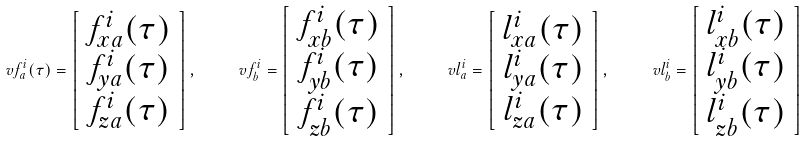Convert formula to latex. <formula><loc_0><loc_0><loc_500><loc_500>\ v f ^ { i } _ { a } ( \tau ) = \left [ \begin{array} { c } f _ { x a } ^ { i } ( \tau ) \\ f _ { y a } ^ { i } ( \tau ) \\ f _ { z a } ^ { i } ( \tau ) \end{array} \right ] , \quad \ v f ^ { i } _ { b } = \left [ \begin{array} { c } f _ { x b } ^ { i } ( \tau ) \\ f _ { y b } ^ { i } ( \tau ) \\ f _ { z b } ^ { i } ( \tau ) \end{array} \right ] , \quad \ v l ^ { i } _ { a } = \left [ \begin{array} { c } l _ { x a } ^ { i } ( \tau ) \\ l _ { y a } ^ { i } ( \tau ) \\ l _ { z a } ^ { i } ( \tau ) \end{array} \right ] , \quad \ v l ^ { i } _ { b } = \left [ \begin{array} { c } l _ { x b } ^ { i } ( \tau ) \\ l _ { y b } ^ { i } ( \tau ) \\ l _ { z b } ^ { i } ( \tau ) \end{array} \right ]</formula> 